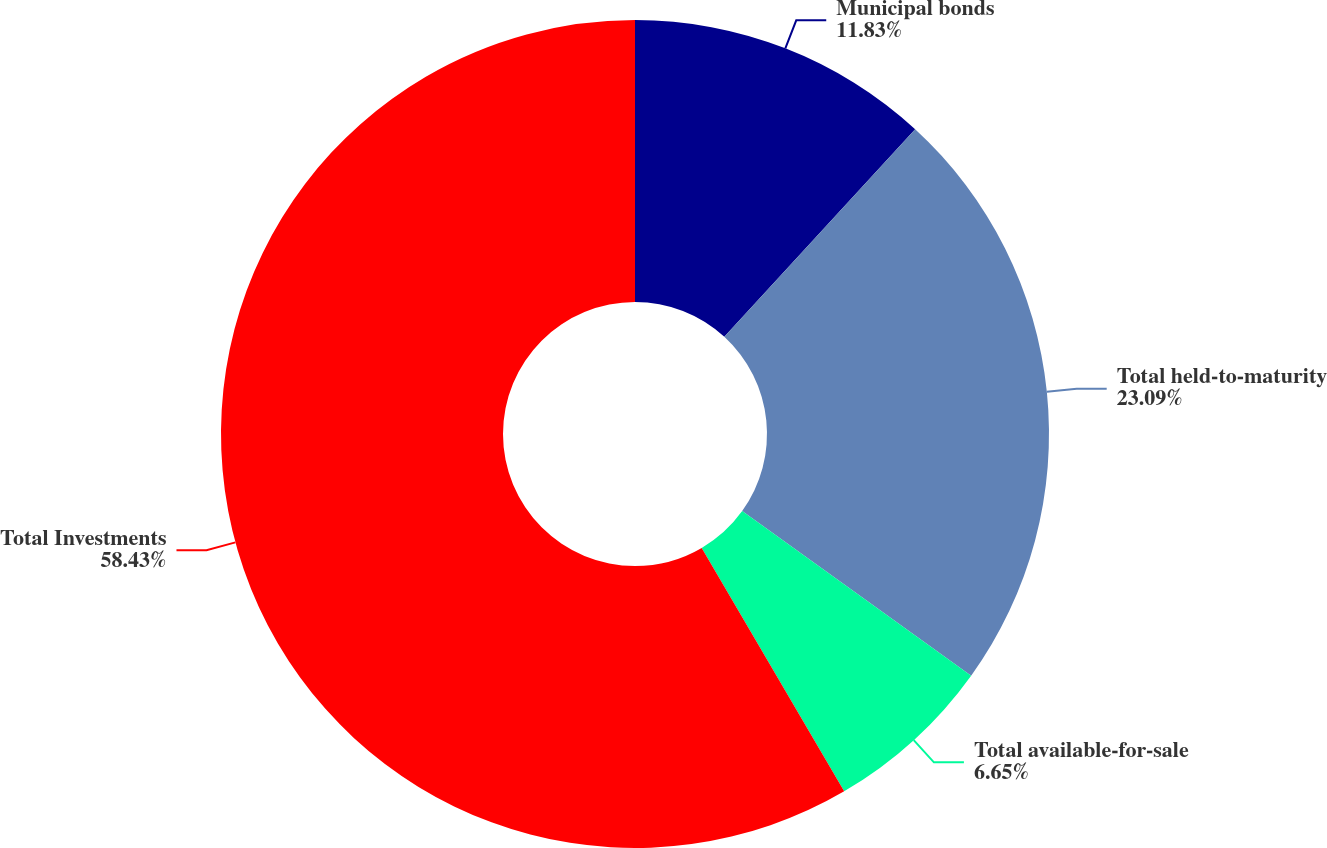Convert chart. <chart><loc_0><loc_0><loc_500><loc_500><pie_chart><fcel>Municipal bonds<fcel>Total held-to-maturity<fcel>Total available-for-sale<fcel>Total Investments<nl><fcel>11.83%<fcel>23.09%<fcel>6.65%<fcel>58.43%<nl></chart> 